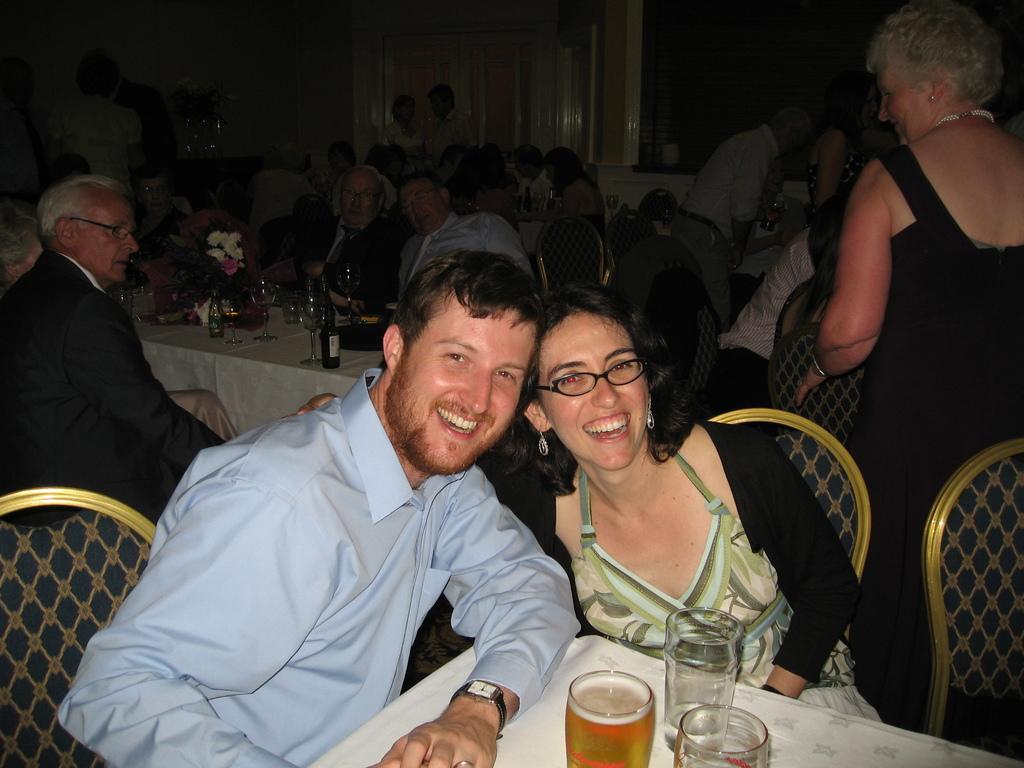Could you give a brief overview of what you see in this image? In this picture I can see a man and woman with a smile. I can see wine glasses and alcohol bottles on the table. I can see a few people sitting on the chair. I can see a few people standing. 